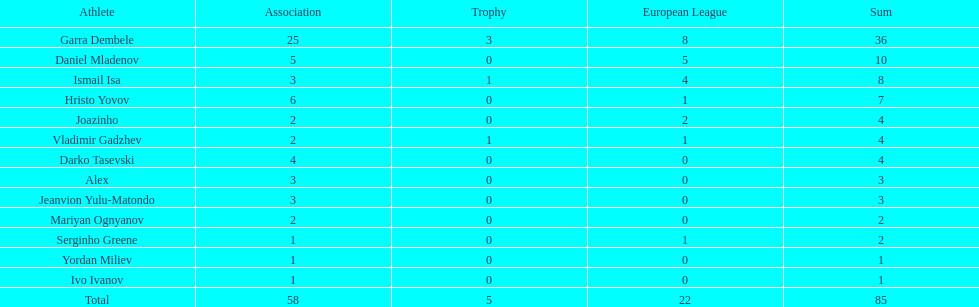Which player is in the same league as joazinho and vladimir gadzhev? Mariyan Ognyanov. 